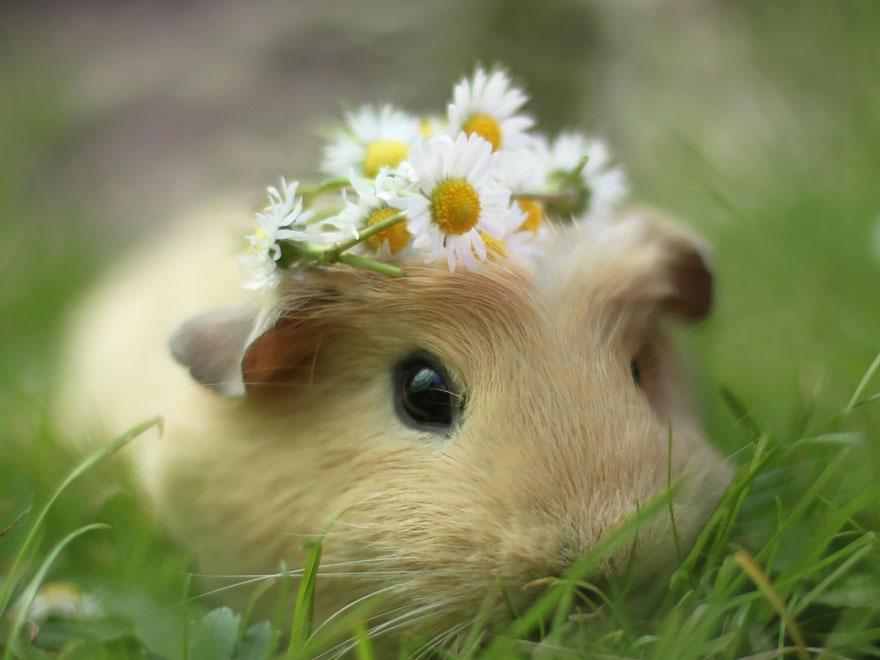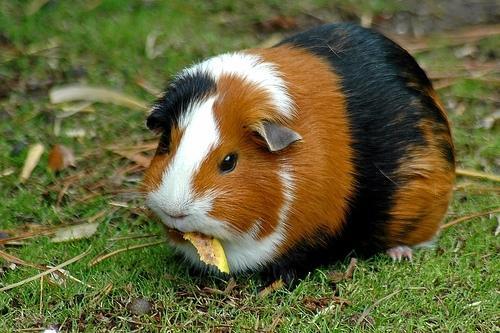The first image is the image on the left, the second image is the image on the right. Considering the images on both sides, is "There are at most two guinea pigs." valid? Answer yes or no. Yes. The first image is the image on the left, the second image is the image on the right. Assess this claim about the two images: "There are two guinea pigs in the left image.". Correct or not? Answer yes or no. No. 